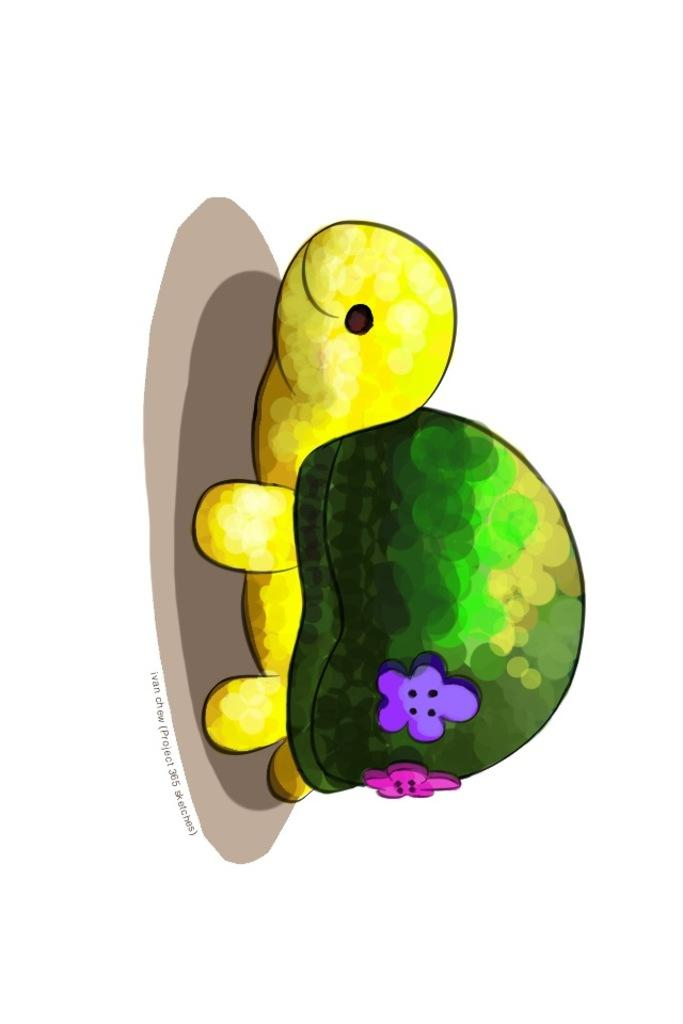What is the main subject of the image? There is a tortoise in the center of the image. What type of image is it? The image is animated. Are there any additional elements on the tortoise? Yes, there are objects on the tortoise. What type of machine can be seen in the image? There is no machine present in the image; it features a tortoise with objects on it. What observation can be made about the tortoise's hair in the image? There is no hair on the tortoise in the image, as tortoises do not have hair. 